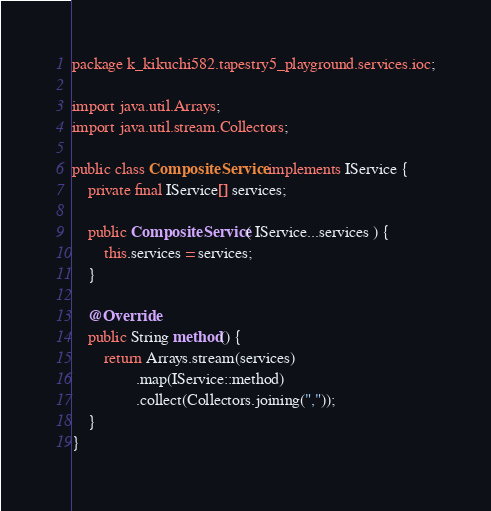Convert code to text. <code><loc_0><loc_0><loc_500><loc_500><_Java_>package k_kikuchi582.tapestry5_playground.services.ioc;

import java.util.Arrays;
import java.util.stream.Collectors;

public class CompositeService implements IService {
    private final IService[] services;

    public CompositeService( IService...services ) {
        this.services = services;
    }

    @Override
    public String method() {
        return Arrays.stream(services)
                .map(IService::method)
                .collect(Collectors.joining(","));
    }
}
</code> 